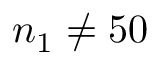Convert formula to latex. <formula><loc_0><loc_0><loc_500><loc_500>n _ { 1 } \neq 5 0</formula> 